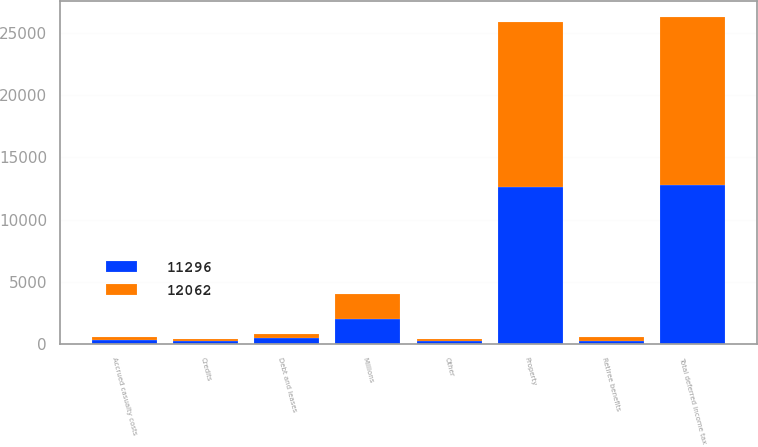<chart> <loc_0><loc_0><loc_500><loc_500><stacked_bar_chart><ecel><fcel>Millions<fcel>Property<fcel>Other<fcel>Total deferred income tax<fcel>Accrued casualty costs<fcel>Debt and leases<fcel>Retiree benefits<fcel>Credits<nl><fcel>12062<fcel>2011<fcel>13312<fcel>207<fcel>13519<fcel>259<fcel>365<fcel>342<fcel>197<nl><fcel>11296<fcel>2010<fcel>12581<fcel>178<fcel>12759<fcel>300<fcel>452<fcel>223<fcel>197<nl></chart> 